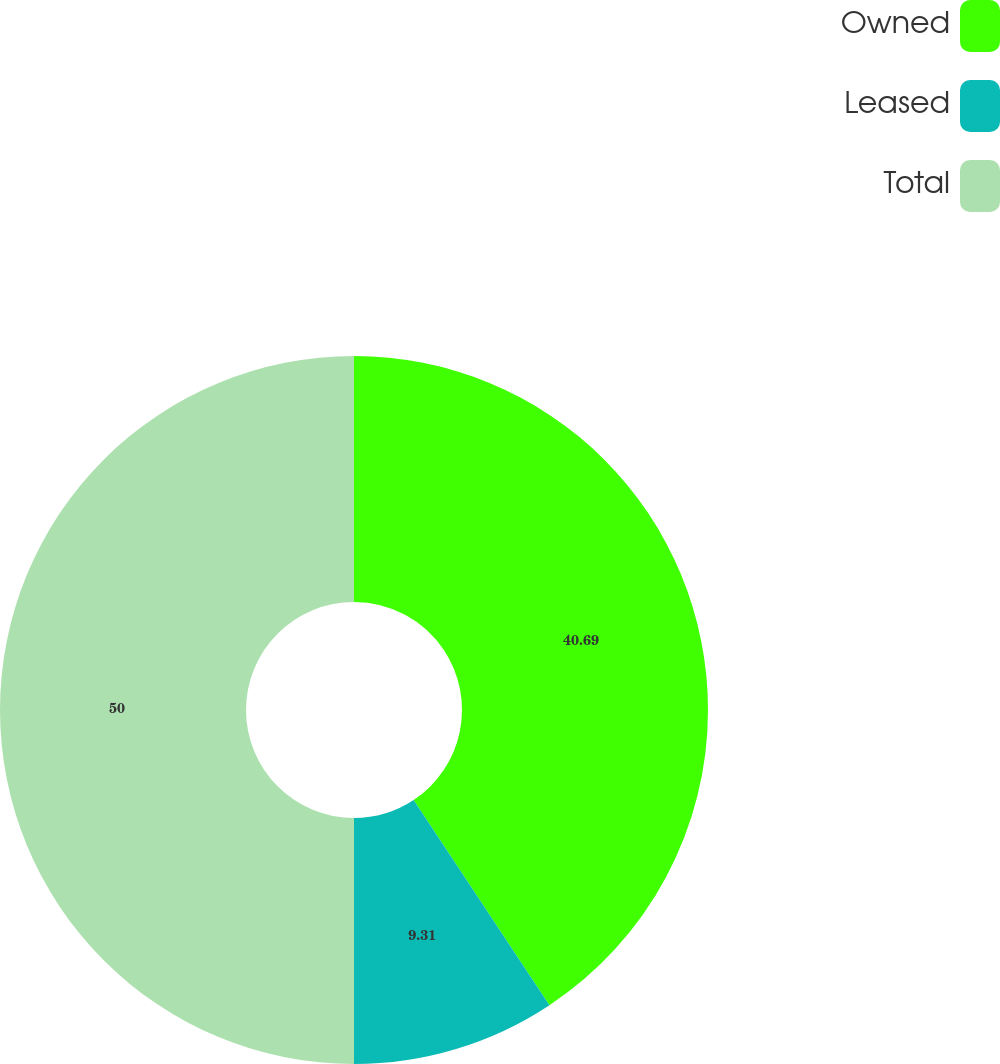<chart> <loc_0><loc_0><loc_500><loc_500><pie_chart><fcel>Owned<fcel>Leased<fcel>Total<nl><fcel>40.69%<fcel>9.31%<fcel>50.0%<nl></chart> 